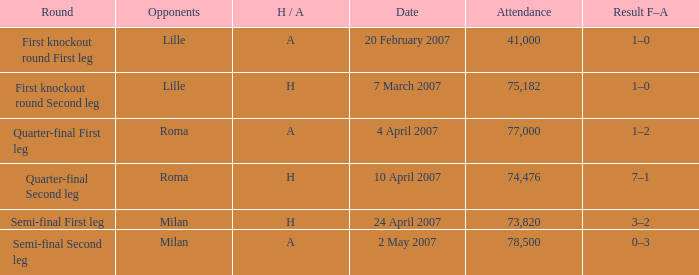Which date has roma as opponent and a H/A of A? 4 April 2007. 